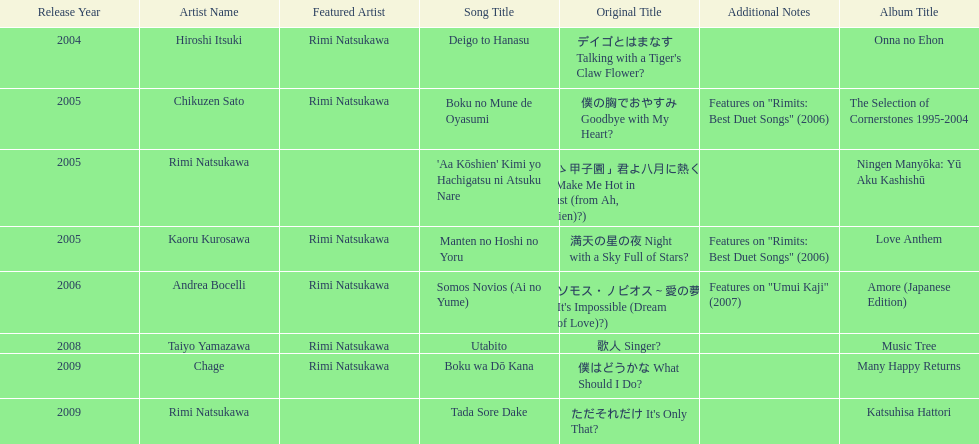Which year had the most titles released? 2005. 